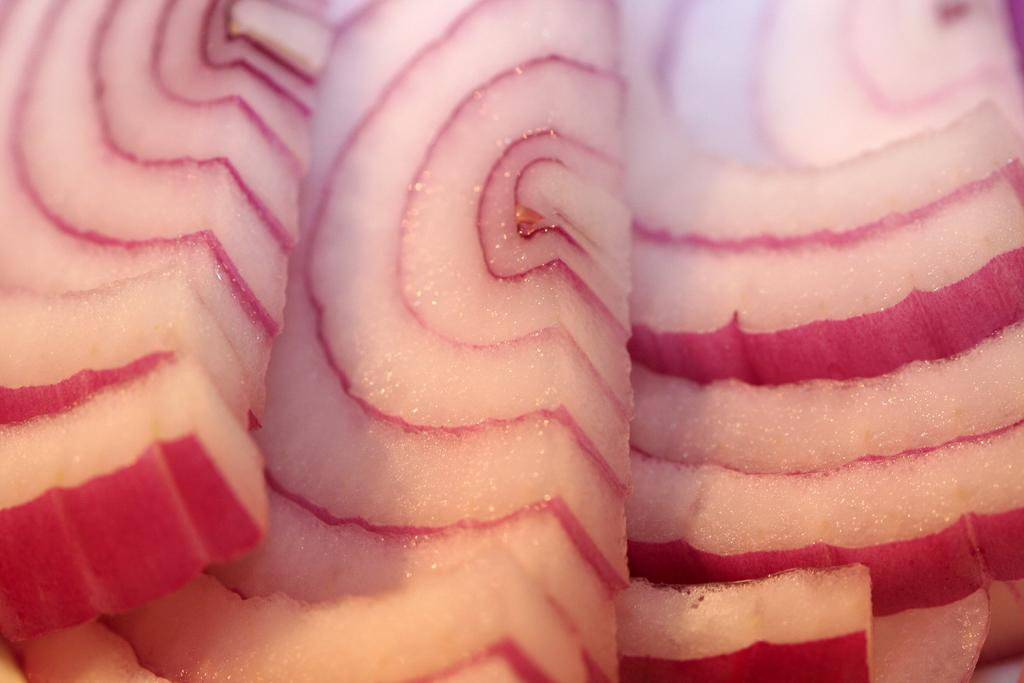What type of food item is visible in the image? There are onion pieces in the image. Can you describe the color of the onion pieces? The onion pieces have a white and pink color combination. What type of plot is being discussed in the image? There is no plot present in the image, as it features onion pieces with a white and pink color combination. 